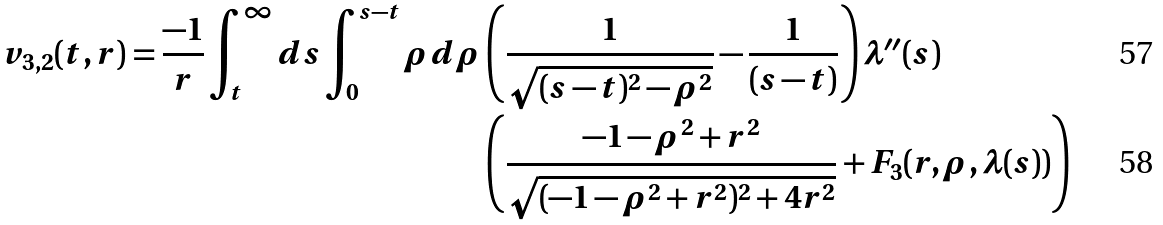Convert formula to latex. <formula><loc_0><loc_0><loc_500><loc_500>v _ { 3 , 2 } ( t , r ) = \frac { - 1 } { r } \int _ { t } ^ { \infty } d s \int _ { 0 } ^ { s - t } \rho d \rho & \left ( \frac { 1 } { \sqrt { ( s - t ) ^ { 2 } - \rho ^ { 2 } } } - \frac { 1 } { ( s - t ) } \right ) \lambda ^ { \prime \prime } ( s ) \\ & \left ( \frac { - 1 - \rho ^ { 2 } + r ^ { 2 } } { \sqrt { ( - 1 - \rho ^ { 2 } + r ^ { 2 } ) ^ { 2 } + 4 r ^ { 2 } } } + F _ { 3 } ( r , \rho , \lambda ( s ) ) \right )</formula> 